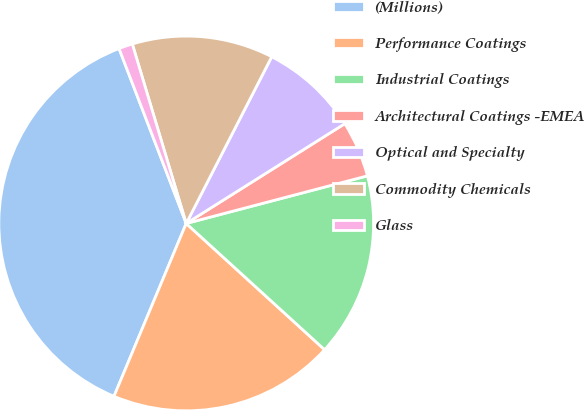Convert chart. <chart><loc_0><loc_0><loc_500><loc_500><pie_chart><fcel>(Millions)<fcel>Performance Coatings<fcel>Industrial Coatings<fcel>Architectural Coatings -EMEA<fcel>Optical and Specialty<fcel>Commodity Chemicals<fcel>Glass<nl><fcel>37.87%<fcel>19.53%<fcel>15.86%<fcel>4.85%<fcel>8.52%<fcel>12.19%<fcel>1.19%<nl></chart> 